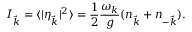<formula> <loc_0><loc_0><loc_500><loc_500>I _ { \vec { k } } = \langle | \eta _ { \vec { k } } | ^ { 2 } \rangle = \frac { 1 } { 2 } \frac { \omega _ { k } } { g } ( n _ { \vec { k } } + n _ { - \vec { k } } ) .</formula> 